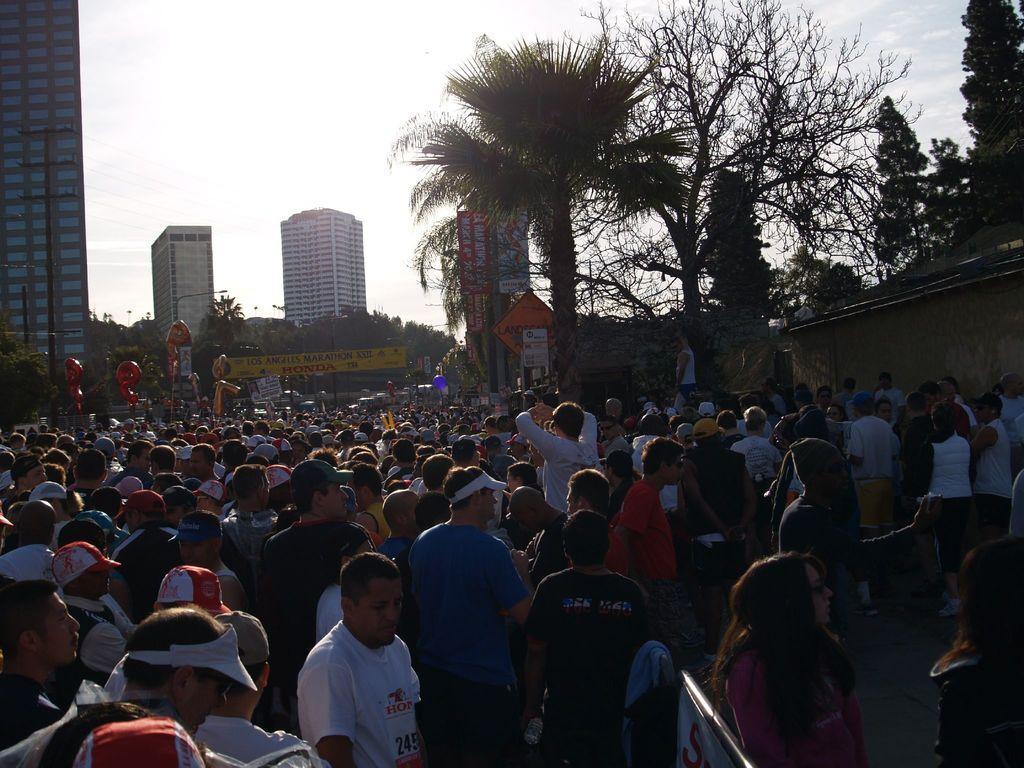How would you summarize this image in a sentence or two? In the foreground of the picture we can see crowd. In the middle of the picture there are trees, buildings and various objects. At the top there is sky. 